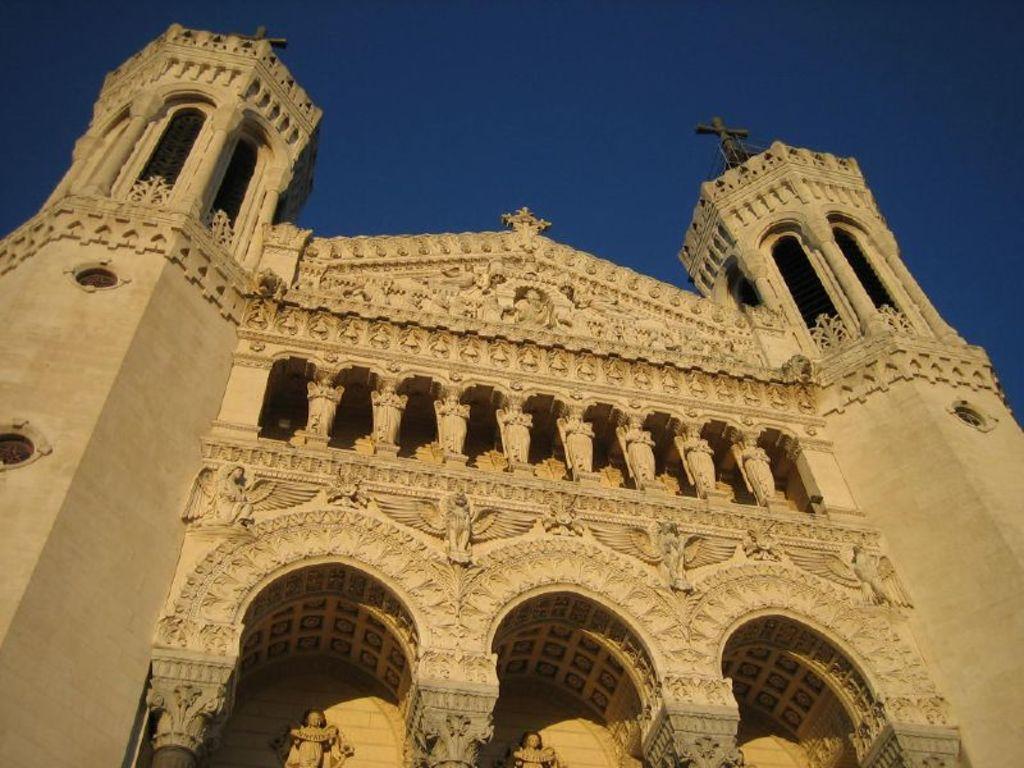Can you describe this image briefly? In the image we can see the building, an arch and cross symbol on the building, and the sky. 